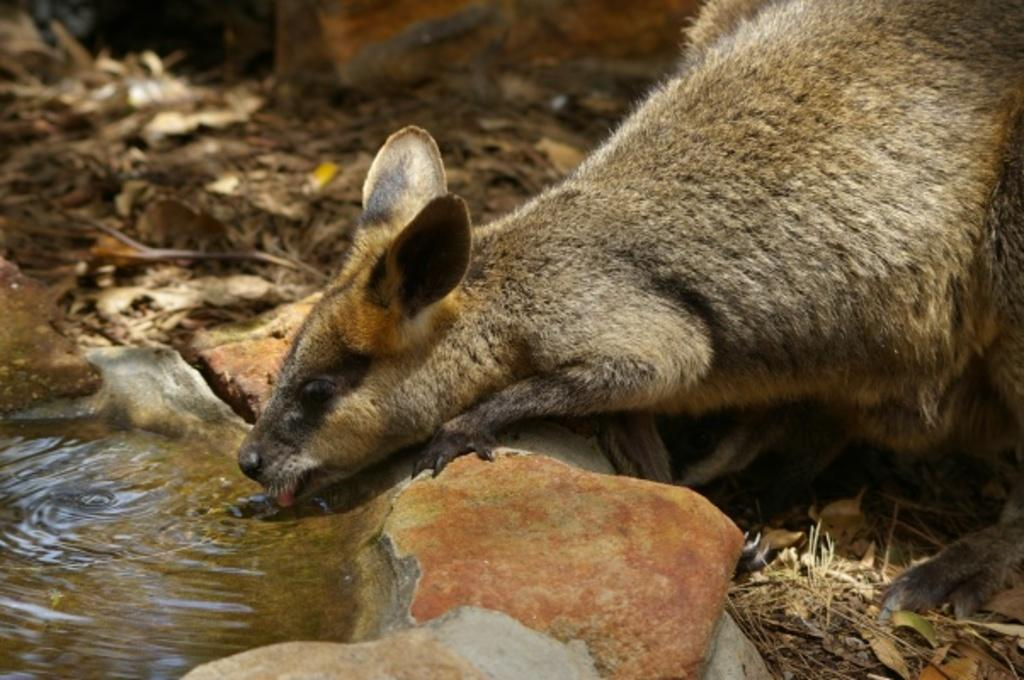What is the main subject of the picture? There is an animal in the picture. What is the animal doing in the image? The animal is drinking water. What can be seen around the water in the image? There are rocks around the water. What other natural elements are visible in the image? There are twigs and dried leaves present on the surface. What type of park can be seen in the background of the image? There is no park visible in the image; it features an animal drinking water near rocks, twigs, and dried leaves. 